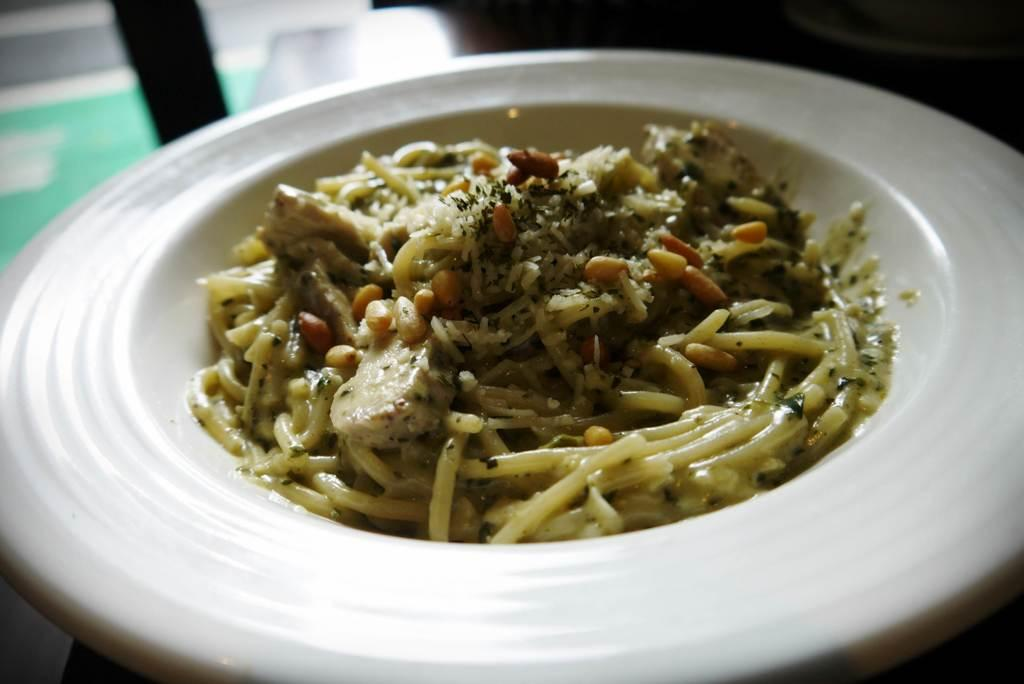What is present in the image? There is a dish in the image. How is the dish being served? The dish is served in a plate. What type of snakes can be seen enjoying the dish in the image? There are no snakes present in the image, and the dish is not being enjoyed by any animals. 